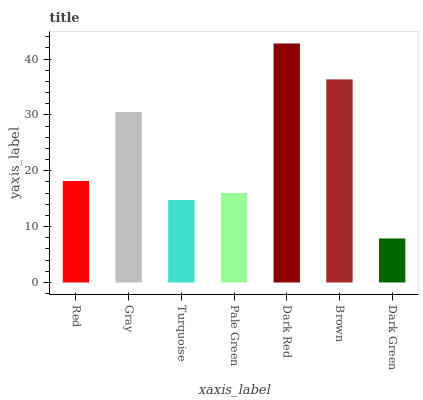Is Dark Green the minimum?
Answer yes or no. Yes. Is Dark Red the maximum?
Answer yes or no. Yes. Is Gray the minimum?
Answer yes or no. No. Is Gray the maximum?
Answer yes or no. No. Is Gray greater than Red?
Answer yes or no. Yes. Is Red less than Gray?
Answer yes or no. Yes. Is Red greater than Gray?
Answer yes or no. No. Is Gray less than Red?
Answer yes or no. No. Is Red the high median?
Answer yes or no. Yes. Is Red the low median?
Answer yes or no. Yes. Is Pale Green the high median?
Answer yes or no. No. Is Dark Green the low median?
Answer yes or no. No. 